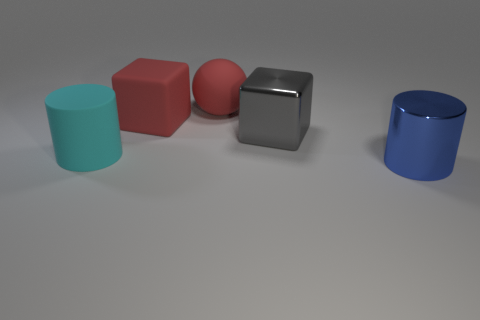Add 1 big brown matte objects. How many objects exist? 6 Subtract all cylinders. How many objects are left? 3 Add 2 large red rubber balls. How many large red rubber balls are left? 3 Add 1 gray metallic blocks. How many gray metallic blocks exist? 2 Subtract 0 purple cylinders. How many objects are left? 5 Subtract all large gray blocks. Subtract all big gray metal things. How many objects are left? 3 